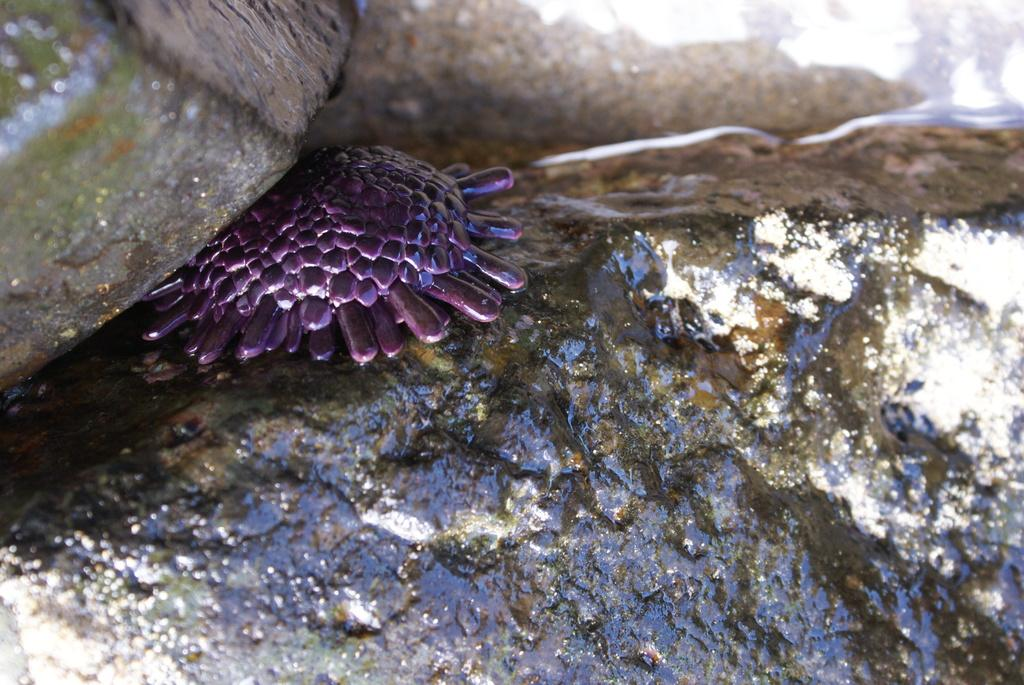What type of object is located in the image? There is a plastic toy in the image. Where is the plastic toy positioned in relation to other objects? The plastic toy is under a rock. How many eyes does the plastic toy have in the image? The provided facts do not mention the number of eyes on the plastic toy, so it cannot be determined from the image. 